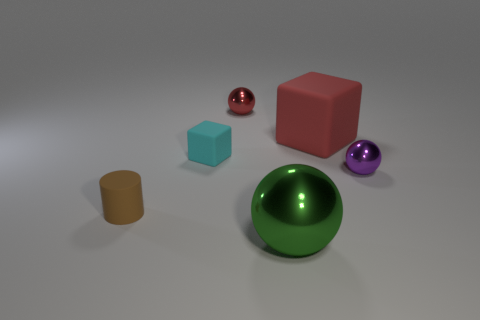Subtract all cyan blocks. Subtract all purple cylinders. How many blocks are left? 1 Add 3 cylinders. How many objects exist? 9 Subtract all blocks. How many objects are left? 4 Add 6 brown objects. How many brown objects are left? 7 Add 2 cubes. How many cubes exist? 4 Subtract 0 green cubes. How many objects are left? 6 Subtract all purple shiny balls. Subtract all small purple shiny objects. How many objects are left? 4 